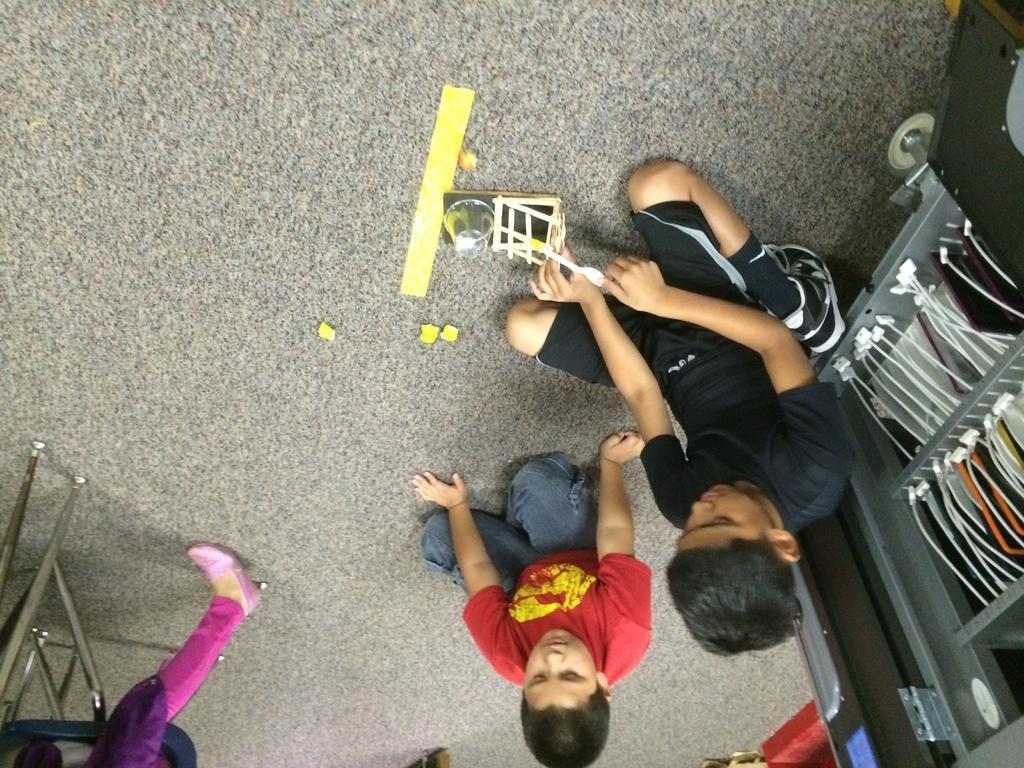How would you summarize this image in a sentence or two? In this picture there are two people sitting on the floor and there are objects on the floor. On the right side of the image there is an object. On the left side of the image it looks like a chair and there might be a person sitting on the chair. 